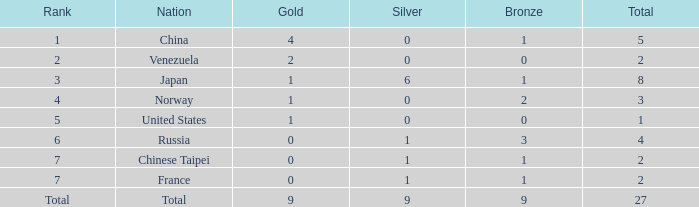What is the sum of Total when rank is 2? 2.0. 